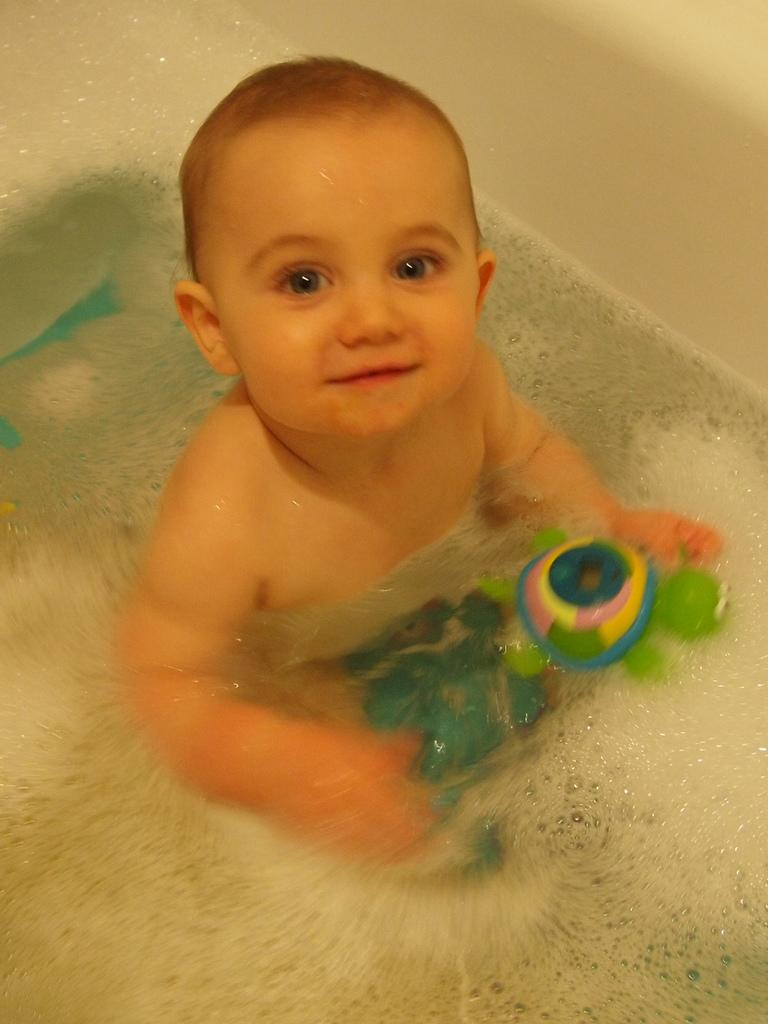What is the main subject of the image? There is a baby in the image. Where is the baby located? The baby is sitting inside a bathtub. What can be found in the bathtub with the baby? There is water and toys in the bathtub. What color are the baby's eyes in the image? The provided facts do not mention the color of the baby's eyes, so we cannot determine that information from the image. 